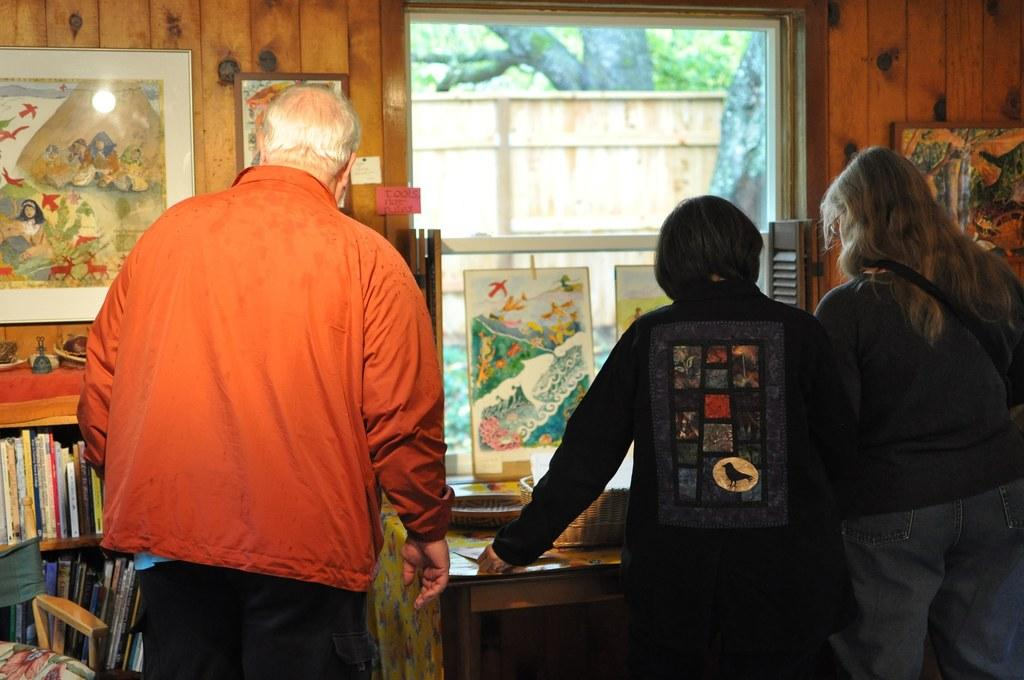What objects are present in the image that are related to displaying images or artwork? There are photo frames in the image, and there are paintings in the photo frames. How many people are in the image, and what are they doing? There are three persons standing and observing the photo frames. What can be seen on the desk in the image? There are books arranged in a desk. What type of furniture is present in the image? There is a chair in the image. What type of credit card is visible in the image? There is no credit card present in the image. What time of day is depicted in the image? The time of day cannot be determined from the image, as there are no specific time-related details provided. 